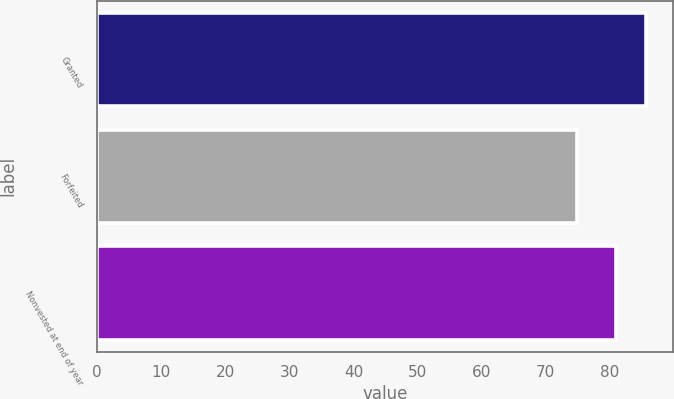Convert chart to OTSL. <chart><loc_0><loc_0><loc_500><loc_500><bar_chart><fcel>Granted<fcel>Forfeited<fcel>Nonvested at end of year<nl><fcel>85.62<fcel>74.87<fcel>80.91<nl></chart> 